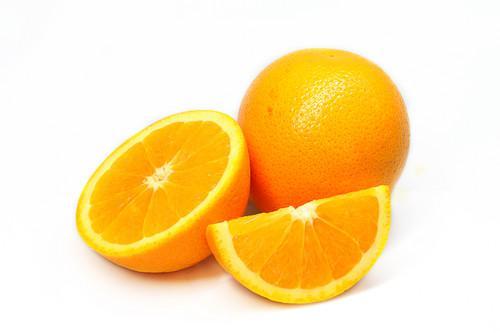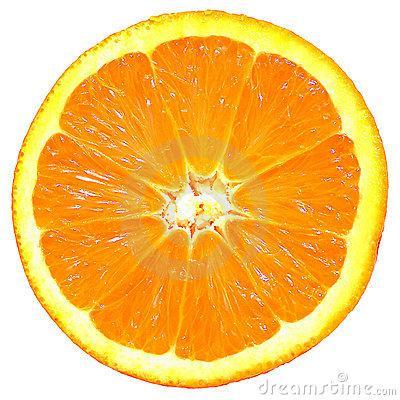The first image is the image on the left, the second image is the image on the right. Considering the images on both sides, is "There is a whole citrus fruit in one of the images." valid? Answer yes or no. Yes. The first image is the image on the left, the second image is the image on the right. Analyze the images presented: Is the assertion "Some of the oranges are cut, some are whole." valid? Answer yes or no. Yes. 